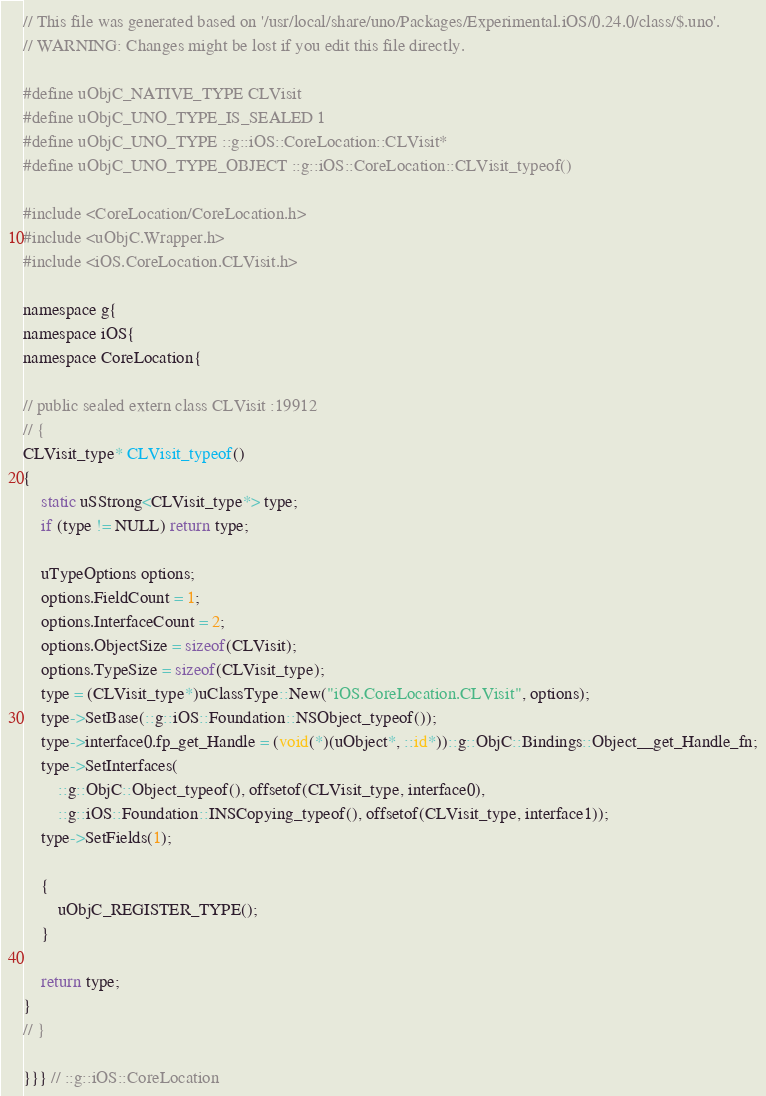Convert code to text. <code><loc_0><loc_0><loc_500><loc_500><_ObjectiveC_>// This file was generated based on '/usr/local/share/uno/Packages/Experimental.iOS/0.24.0/class/$.uno'.
// WARNING: Changes might be lost if you edit this file directly.

#define uObjC_NATIVE_TYPE CLVisit
#define uObjC_UNO_TYPE_IS_SEALED 1
#define uObjC_UNO_TYPE ::g::iOS::CoreLocation::CLVisit*
#define uObjC_UNO_TYPE_OBJECT ::g::iOS::CoreLocation::CLVisit_typeof()

#include <CoreLocation/CoreLocation.h>
#include <uObjC.Wrapper.h>
#include <iOS.CoreLocation.CLVisit.h>

namespace g{
namespace iOS{
namespace CoreLocation{

// public sealed extern class CLVisit :19912
// {
CLVisit_type* CLVisit_typeof()
{
    static uSStrong<CLVisit_type*> type;
    if (type != NULL) return type;

    uTypeOptions options;
    options.FieldCount = 1;
    options.InterfaceCount = 2;
    options.ObjectSize = sizeof(CLVisit);
    options.TypeSize = sizeof(CLVisit_type);
    type = (CLVisit_type*)uClassType::New("iOS.CoreLocation.CLVisit", options);
    type->SetBase(::g::iOS::Foundation::NSObject_typeof());
    type->interface0.fp_get_Handle = (void(*)(uObject*, ::id*))::g::ObjC::Bindings::Object__get_Handle_fn;
    type->SetInterfaces(
        ::g::ObjC::Object_typeof(), offsetof(CLVisit_type, interface0),
        ::g::iOS::Foundation::INSCopying_typeof(), offsetof(CLVisit_type, interface1));
    type->SetFields(1);

    {
        uObjC_REGISTER_TYPE();
    }

    return type;
}
// }

}}} // ::g::iOS::CoreLocation
</code> 